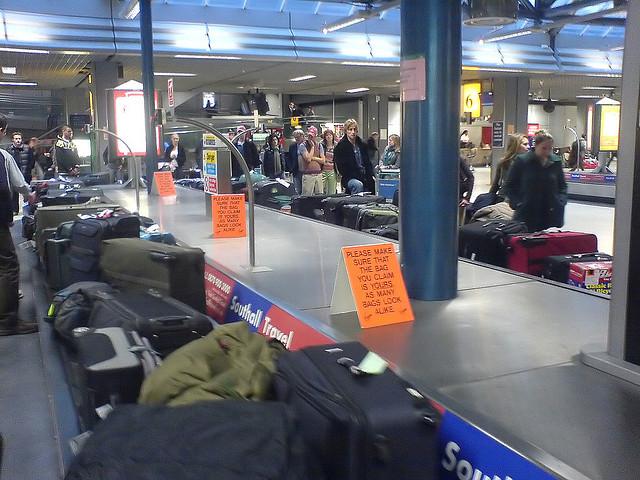What does the first sign say?
Give a very brief answer. Please make sure that bag you claim is yours as many bags look alike. What place does this look like?
Quick response, please. Airport. What color are the signs?
Give a very brief answer. Orange. 